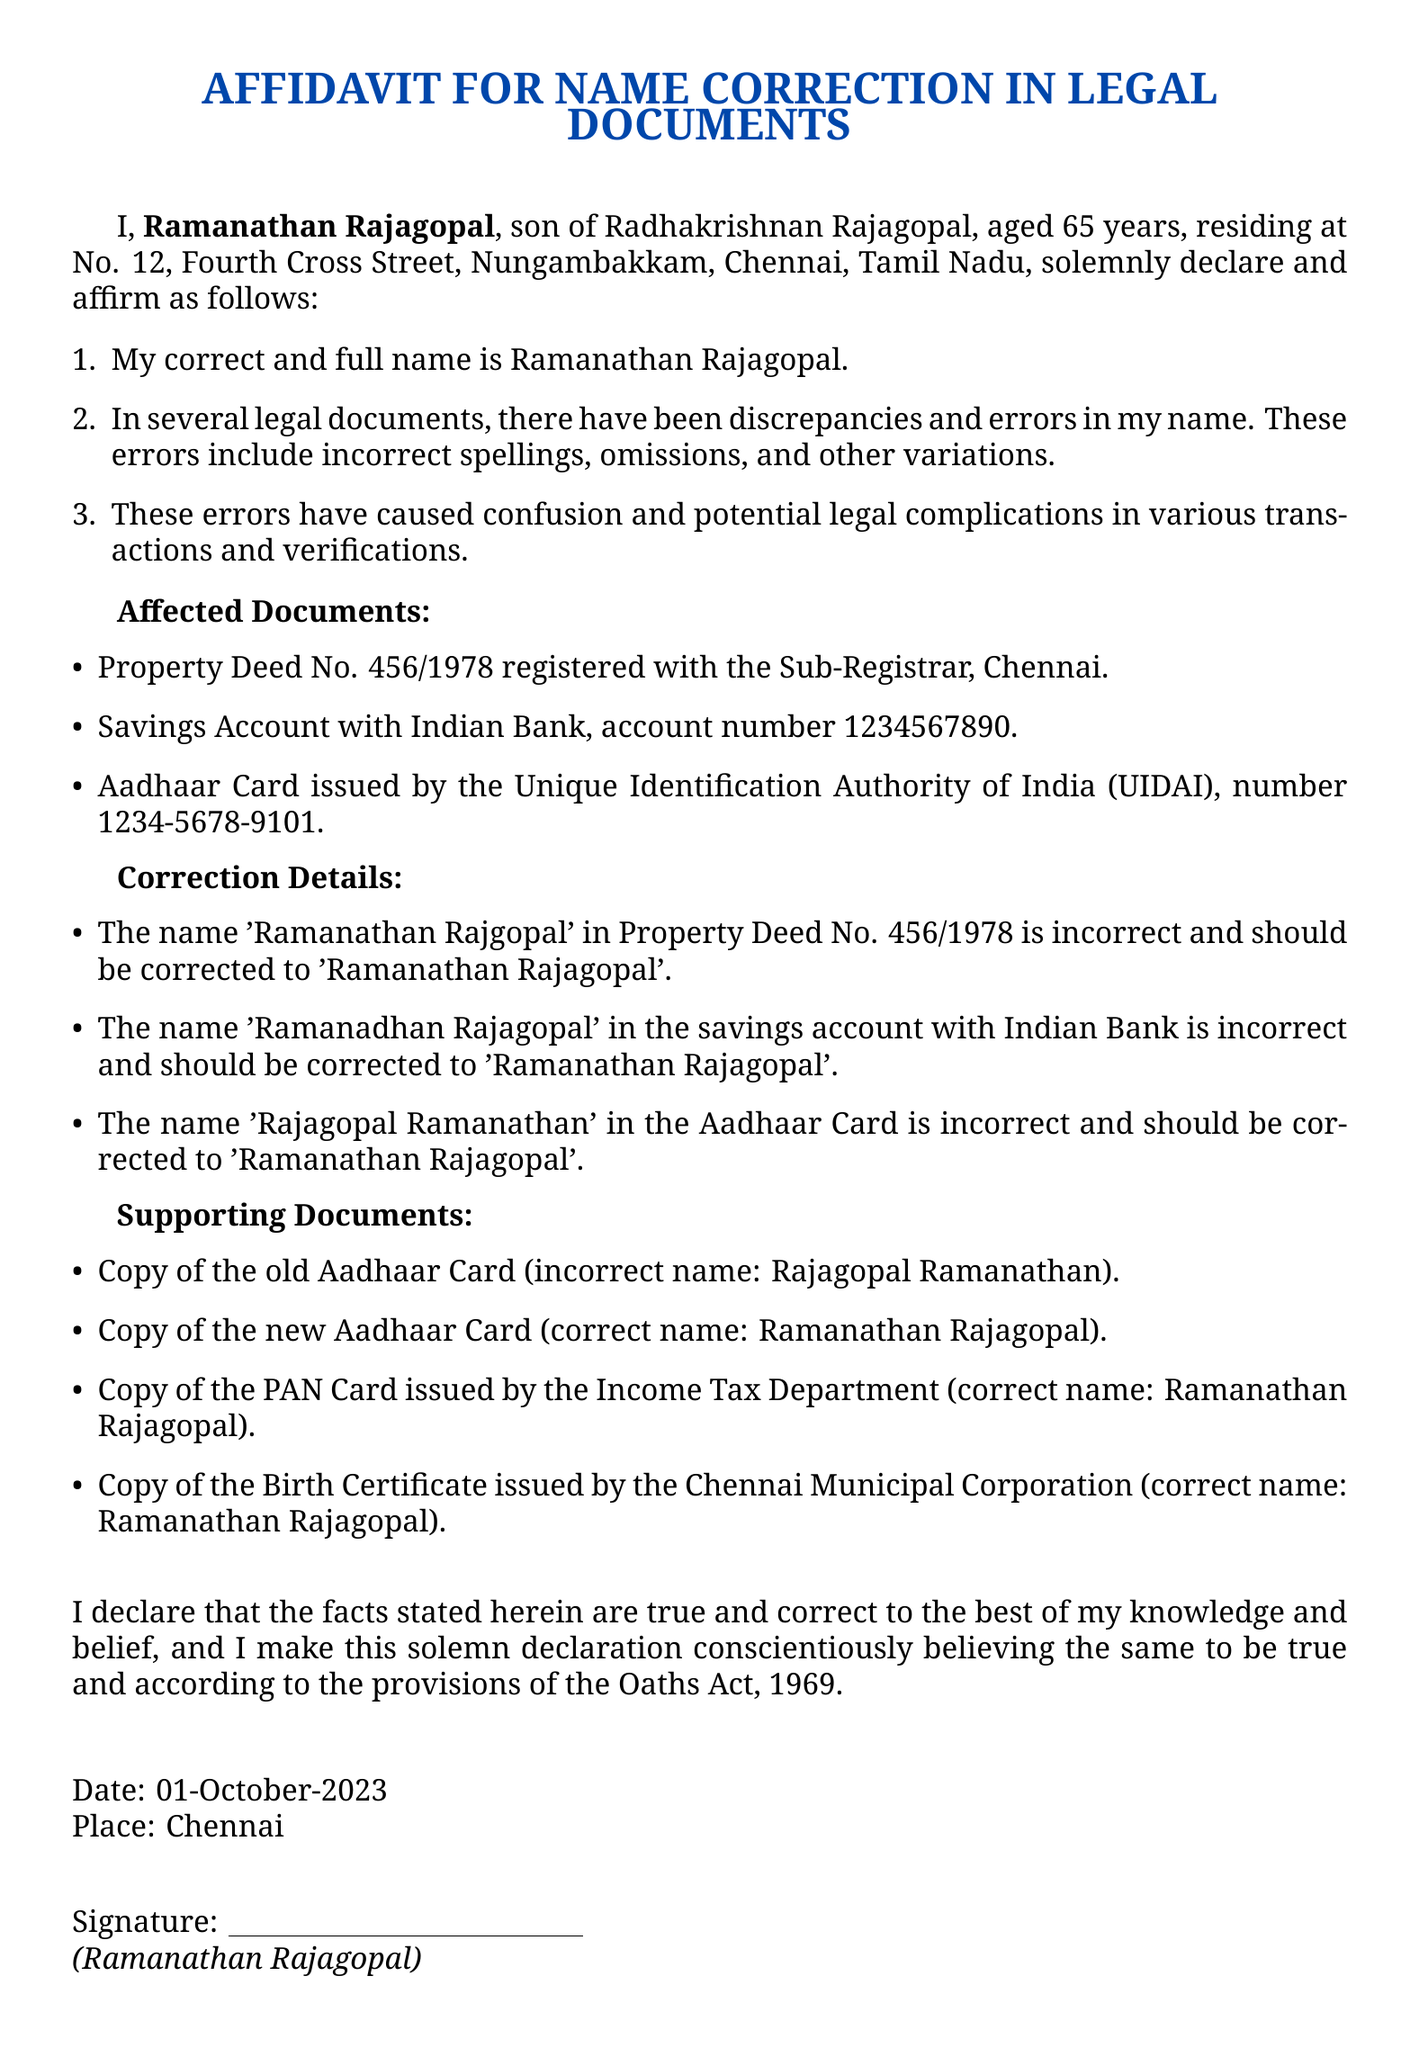What is the name of the declarant? The declarant's name, as mentioned in the affidavit, is Ramanathan Rajagopal.
Answer: Ramanathan Rajagopal How many years old is the declarant? The document states that the declarant is 65 years old.
Answer: 65 What is the place of residence of the declarant? The place of residence provided in the affidavit is No. 12, Fourth Cross Street, Nungambakkam, Chennai, Tamil Nadu.
Answer: No. 12, Fourth Cross Street, Nungambakkam, Chennai, Tamil Nadu What document number is mentioned for the property deed? The property deed number given in the affidavit is 456/1978.
Answer: 456/1978 What incorrect name is listed on the Aadhaar Card? The incorrect name mentioned on the Aadhaar Card is Rajagopal Ramanathan.
Answer: Rajagopal Ramanathan What is the correct name to be used in the savings account? The correct name to be used in the savings account is Ramanathan Rajagopal.
Answer: Ramanathan Rajagopal What supporting document is required for correction? A copy of the old Aadhaar Card is listed as a supporting document for correction.
Answer: Copy of the old Aadhaar Card What is the date of the affidavit? The date on the affidavit is 01-October-2023.
Answer: 01-October-2023 What act does the declarant refer to in making the declaration? The declarant refers to the provisions of the Oaths Act, 1969.
Answer: Oaths Act, 1969 Where is this affidavit sworn? The location mentioned for swearing the affidavit is Chennai.
Answer: Chennai 